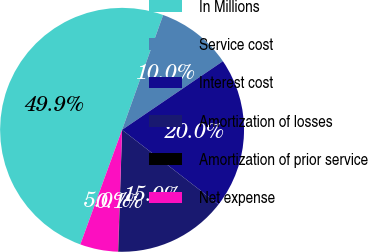<chart> <loc_0><loc_0><loc_500><loc_500><pie_chart><fcel>In Millions<fcel>Service cost<fcel>Interest cost<fcel>Amortization of losses<fcel>Amortization of prior service<fcel>Net expense<nl><fcel>49.91%<fcel>10.02%<fcel>19.99%<fcel>15.0%<fcel>0.05%<fcel>5.03%<nl></chart> 